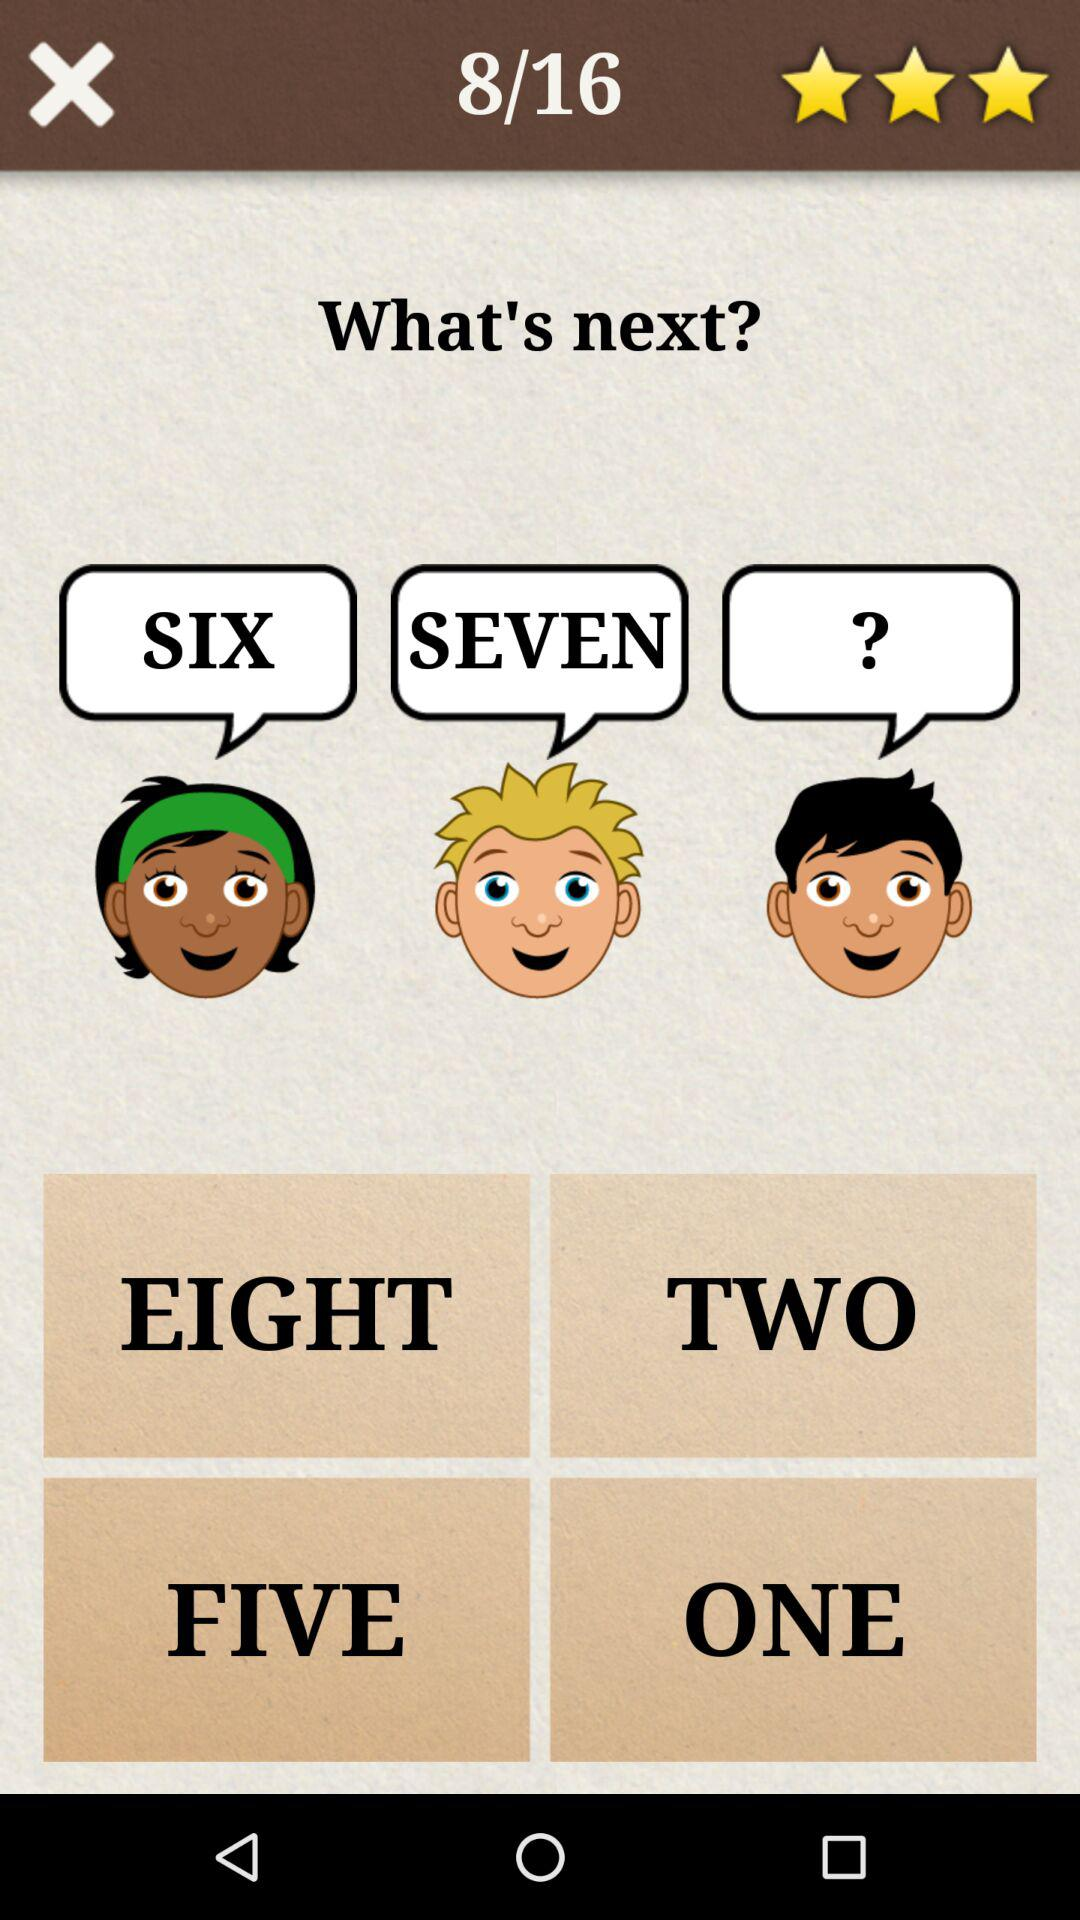How many questions are there? There are 16 questions. 